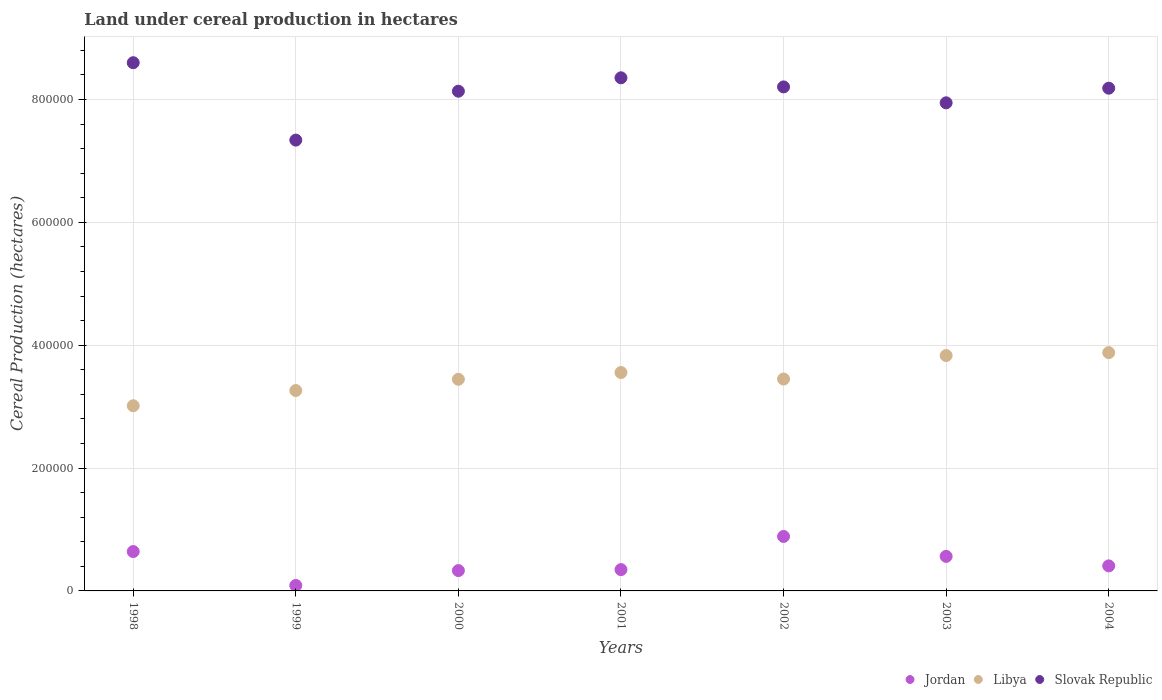How many different coloured dotlines are there?
Your answer should be compact. 3. Is the number of dotlines equal to the number of legend labels?
Offer a very short reply. Yes. What is the land under cereal production in Jordan in 2003?
Your answer should be very brief. 5.62e+04. Across all years, what is the maximum land under cereal production in Slovak Republic?
Your answer should be compact. 8.60e+05. Across all years, what is the minimum land under cereal production in Libya?
Your response must be concise. 3.01e+05. In which year was the land under cereal production in Jordan maximum?
Make the answer very short. 2002. What is the total land under cereal production in Jordan in the graph?
Provide a succinct answer. 3.26e+05. What is the difference between the land under cereal production in Libya in 1998 and that in 2003?
Your answer should be very brief. -8.17e+04. What is the difference between the land under cereal production in Slovak Republic in 2004 and the land under cereal production in Libya in 2001?
Provide a short and direct response. 4.63e+05. What is the average land under cereal production in Libya per year?
Offer a very short reply. 3.49e+05. In the year 2001, what is the difference between the land under cereal production in Slovak Republic and land under cereal production in Jordan?
Ensure brevity in your answer.  8.01e+05. What is the ratio of the land under cereal production in Slovak Republic in 1999 to that in 2003?
Your response must be concise. 0.92. Is the land under cereal production in Libya in 2002 less than that in 2003?
Provide a succinct answer. Yes. Is the difference between the land under cereal production in Slovak Republic in 1999 and 2002 greater than the difference between the land under cereal production in Jordan in 1999 and 2002?
Keep it short and to the point. No. What is the difference between the highest and the second highest land under cereal production in Slovak Republic?
Make the answer very short. 2.46e+04. What is the difference between the highest and the lowest land under cereal production in Jordan?
Offer a very short reply. 7.98e+04. In how many years, is the land under cereal production in Jordan greater than the average land under cereal production in Jordan taken over all years?
Provide a short and direct response. 3. Is the sum of the land under cereal production in Slovak Republic in 1999 and 2002 greater than the maximum land under cereal production in Libya across all years?
Your answer should be compact. Yes. Is it the case that in every year, the sum of the land under cereal production in Jordan and land under cereal production in Slovak Republic  is greater than the land under cereal production in Libya?
Provide a succinct answer. Yes. Does the land under cereal production in Jordan monotonically increase over the years?
Make the answer very short. No. Is the land under cereal production in Jordan strictly greater than the land under cereal production in Slovak Republic over the years?
Give a very brief answer. No. How many dotlines are there?
Keep it short and to the point. 3. How many years are there in the graph?
Ensure brevity in your answer.  7. What is the difference between two consecutive major ticks on the Y-axis?
Offer a very short reply. 2.00e+05. Are the values on the major ticks of Y-axis written in scientific E-notation?
Give a very brief answer. No. Does the graph contain grids?
Ensure brevity in your answer.  Yes. Where does the legend appear in the graph?
Provide a short and direct response. Bottom right. How are the legend labels stacked?
Your answer should be compact. Horizontal. What is the title of the graph?
Offer a terse response. Land under cereal production in hectares. What is the label or title of the Y-axis?
Ensure brevity in your answer.  Cereal Production (hectares). What is the Cereal Production (hectares) in Jordan in 1998?
Your response must be concise. 6.41e+04. What is the Cereal Production (hectares) of Libya in 1998?
Offer a terse response. 3.01e+05. What is the Cereal Production (hectares) in Slovak Republic in 1998?
Provide a short and direct response. 8.60e+05. What is the Cereal Production (hectares) of Jordan in 1999?
Your answer should be very brief. 8880. What is the Cereal Production (hectares) in Libya in 1999?
Your response must be concise. 3.26e+05. What is the Cereal Production (hectares) in Slovak Republic in 1999?
Keep it short and to the point. 7.34e+05. What is the Cereal Production (hectares) of Jordan in 2000?
Give a very brief answer. 3.31e+04. What is the Cereal Production (hectares) of Libya in 2000?
Your response must be concise. 3.44e+05. What is the Cereal Production (hectares) in Slovak Republic in 2000?
Offer a very short reply. 8.13e+05. What is the Cereal Production (hectares) in Jordan in 2001?
Give a very brief answer. 3.47e+04. What is the Cereal Production (hectares) of Libya in 2001?
Provide a short and direct response. 3.56e+05. What is the Cereal Production (hectares) of Slovak Republic in 2001?
Offer a very short reply. 8.35e+05. What is the Cereal Production (hectares) of Jordan in 2002?
Give a very brief answer. 8.87e+04. What is the Cereal Production (hectares) in Libya in 2002?
Offer a terse response. 3.45e+05. What is the Cereal Production (hectares) in Slovak Republic in 2002?
Keep it short and to the point. 8.20e+05. What is the Cereal Production (hectares) in Jordan in 2003?
Your answer should be compact. 5.62e+04. What is the Cereal Production (hectares) in Libya in 2003?
Give a very brief answer. 3.83e+05. What is the Cereal Production (hectares) of Slovak Republic in 2003?
Provide a short and direct response. 7.95e+05. What is the Cereal Production (hectares) of Jordan in 2004?
Offer a very short reply. 4.08e+04. What is the Cereal Production (hectares) in Libya in 2004?
Your response must be concise. 3.88e+05. What is the Cereal Production (hectares) of Slovak Republic in 2004?
Your response must be concise. 8.18e+05. Across all years, what is the maximum Cereal Production (hectares) of Jordan?
Provide a succinct answer. 8.87e+04. Across all years, what is the maximum Cereal Production (hectares) of Libya?
Provide a short and direct response. 3.88e+05. Across all years, what is the maximum Cereal Production (hectares) of Slovak Republic?
Make the answer very short. 8.60e+05. Across all years, what is the minimum Cereal Production (hectares) in Jordan?
Offer a very short reply. 8880. Across all years, what is the minimum Cereal Production (hectares) of Libya?
Offer a very short reply. 3.01e+05. Across all years, what is the minimum Cereal Production (hectares) in Slovak Republic?
Ensure brevity in your answer.  7.34e+05. What is the total Cereal Production (hectares) in Jordan in the graph?
Provide a succinct answer. 3.26e+05. What is the total Cereal Production (hectares) in Libya in the graph?
Give a very brief answer. 2.44e+06. What is the total Cereal Production (hectares) of Slovak Republic in the graph?
Your response must be concise. 5.68e+06. What is the difference between the Cereal Production (hectares) of Jordan in 1998 and that in 1999?
Your answer should be compact. 5.52e+04. What is the difference between the Cereal Production (hectares) in Libya in 1998 and that in 1999?
Give a very brief answer. -2.48e+04. What is the difference between the Cereal Production (hectares) in Slovak Republic in 1998 and that in 1999?
Ensure brevity in your answer.  1.26e+05. What is the difference between the Cereal Production (hectares) of Jordan in 1998 and that in 2000?
Offer a terse response. 3.10e+04. What is the difference between the Cereal Production (hectares) of Libya in 1998 and that in 2000?
Ensure brevity in your answer.  -4.31e+04. What is the difference between the Cereal Production (hectares) in Slovak Republic in 1998 and that in 2000?
Keep it short and to the point. 4.64e+04. What is the difference between the Cereal Production (hectares) in Jordan in 1998 and that in 2001?
Ensure brevity in your answer.  2.94e+04. What is the difference between the Cereal Production (hectares) of Libya in 1998 and that in 2001?
Your response must be concise. -5.41e+04. What is the difference between the Cereal Production (hectares) of Slovak Republic in 1998 and that in 2001?
Ensure brevity in your answer.  2.46e+04. What is the difference between the Cereal Production (hectares) in Jordan in 1998 and that in 2002?
Give a very brief answer. -2.46e+04. What is the difference between the Cereal Production (hectares) of Libya in 1998 and that in 2002?
Provide a short and direct response. -4.35e+04. What is the difference between the Cereal Production (hectares) of Slovak Republic in 1998 and that in 2002?
Give a very brief answer. 3.94e+04. What is the difference between the Cereal Production (hectares) in Jordan in 1998 and that in 2003?
Keep it short and to the point. 7858. What is the difference between the Cereal Production (hectares) in Libya in 1998 and that in 2003?
Offer a very short reply. -8.17e+04. What is the difference between the Cereal Production (hectares) of Slovak Republic in 1998 and that in 2003?
Provide a succinct answer. 6.53e+04. What is the difference between the Cereal Production (hectares) of Jordan in 1998 and that in 2004?
Your response must be concise. 2.33e+04. What is the difference between the Cereal Production (hectares) of Libya in 1998 and that in 2004?
Your answer should be very brief. -8.65e+04. What is the difference between the Cereal Production (hectares) of Slovak Republic in 1998 and that in 2004?
Keep it short and to the point. 4.15e+04. What is the difference between the Cereal Production (hectares) of Jordan in 1999 and that in 2000?
Offer a terse response. -2.42e+04. What is the difference between the Cereal Production (hectares) of Libya in 1999 and that in 2000?
Offer a very short reply. -1.83e+04. What is the difference between the Cereal Production (hectares) in Slovak Republic in 1999 and that in 2000?
Your answer should be very brief. -7.96e+04. What is the difference between the Cereal Production (hectares) of Jordan in 1999 and that in 2001?
Offer a very short reply. -2.58e+04. What is the difference between the Cereal Production (hectares) in Libya in 1999 and that in 2001?
Ensure brevity in your answer.  -2.93e+04. What is the difference between the Cereal Production (hectares) of Slovak Republic in 1999 and that in 2001?
Make the answer very short. -1.01e+05. What is the difference between the Cereal Production (hectares) of Jordan in 1999 and that in 2002?
Your response must be concise. -7.98e+04. What is the difference between the Cereal Production (hectares) of Libya in 1999 and that in 2002?
Offer a terse response. -1.87e+04. What is the difference between the Cereal Production (hectares) in Slovak Republic in 1999 and that in 2002?
Your answer should be very brief. -8.66e+04. What is the difference between the Cereal Production (hectares) of Jordan in 1999 and that in 2003?
Keep it short and to the point. -4.73e+04. What is the difference between the Cereal Production (hectares) of Libya in 1999 and that in 2003?
Offer a very short reply. -5.69e+04. What is the difference between the Cereal Production (hectares) of Slovak Republic in 1999 and that in 2003?
Offer a very short reply. -6.07e+04. What is the difference between the Cereal Production (hectares) of Jordan in 1999 and that in 2004?
Offer a very short reply. -3.19e+04. What is the difference between the Cereal Production (hectares) of Libya in 1999 and that in 2004?
Offer a very short reply. -6.17e+04. What is the difference between the Cereal Production (hectares) of Slovak Republic in 1999 and that in 2004?
Your response must be concise. -8.45e+04. What is the difference between the Cereal Production (hectares) in Jordan in 2000 and that in 2001?
Give a very brief answer. -1591. What is the difference between the Cereal Production (hectares) of Libya in 2000 and that in 2001?
Provide a succinct answer. -1.10e+04. What is the difference between the Cereal Production (hectares) in Slovak Republic in 2000 and that in 2001?
Ensure brevity in your answer.  -2.18e+04. What is the difference between the Cereal Production (hectares) in Jordan in 2000 and that in 2002?
Offer a terse response. -5.56e+04. What is the difference between the Cereal Production (hectares) in Libya in 2000 and that in 2002?
Offer a terse response. -398. What is the difference between the Cereal Production (hectares) in Slovak Republic in 2000 and that in 2002?
Your answer should be compact. -6992. What is the difference between the Cereal Production (hectares) in Jordan in 2000 and that in 2003?
Keep it short and to the point. -2.31e+04. What is the difference between the Cereal Production (hectares) in Libya in 2000 and that in 2003?
Give a very brief answer. -3.86e+04. What is the difference between the Cereal Production (hectares) in Slovak Republic in 2000 and that in 2003?
Make the answer very short. 1.89e+04. What is the difference between the Cereal Production (hectares) of Jordan in 2000 and that in 2004?
Provide a short and direct response. -7654. What is the difference between the Cereal Production (hectares) of Libya in 2000 and that in 2004?
Your answer should be very brief. -4.34e+04. What is the difference between the Cereal Production (hectares) in Slovak Republic in 2000 and that in 2004?
Provide a succinct answer. -4902. What is the difference between the Cereal Production (hectares) in Jordan in 2001 and that in 2002?
Provide a short and direct response. -5.40e+04. What is the difference between the Cereal Production (hectares) of Libya in 2001 and that in 2002?
Give a very brief answer. 1.06e+04. What is the difference between the Cereal Production (hectares) in Slovak Republic in 2001 and that in 2002?
Keep it short and to the point. 1.48e+04. What is the difference between the Cereal Production (hectares) in Jordan in 2001 and that in 2003?
Give a very brief answer. -2.15e+04. What is the difference between the Cereal Production (hectares) in Libya in 2001 and that in 2003?
Offer a very short reply. -2.76e+04. What is the difference between the Cereal Production (hectares) in Slovak Republic in 2001 and that in 2003?
Your answer should be compact. 4.07e+04. What is the difference between the Cereal Production (hectares) in Jordan in 2001 and that in 2004?
Provide a short and direct response. -6063. What is the difference between the Cereal Production (hectares) of Libya in 2001 and that in 2004?
Your answer should be compact. -3.24e+04. What is the difference between the Cereal Production (hectares) in Slovak Republic in 2001 and that in 2004?
Provide a short and direct response. 1.69e+04. What is the difference between the Cereal Production (hectares) of Jordan in 2002 and that in 2003?
Provide a succinct answer. 3.25e+04. What is the difference between the Cereal Production (hectares) of Libya in 2002 and that in 2003?
Your answer should be compact. -3.82e+04. What is the difference between the Cereal Production (hectares) in Slovak Republic in 2002 and that in 2003?
Your response must be concise. 2.59e+04. What is the difference between the Cereal Production (hectares) in Jordan in 2002 and that in 2004?
Give a very brief answer. 4.79e+04. What is the difference between the Cereal Production (hectares) of Libya in 2002 and that in 2004?
Ensure brevity in your answer.  -4.30e+04. What is the difference between the Cereal Production (hectares) of Slovak Republic in 2002 and that in 2004?
Offer a very short reply. 2090. What is the difference between the Cereal Production (hectares) in Jordan in 2003 and that in 2004?
Keep it short and to the point. 1.55e+04. What is the difference between the Cereal Production (hectares) in Libya in 2003 and that in 2004?
Provide a succinct answer. -4773. What is the difference between the Cereal Production (hectares) in Slovak Republic in 2003 and that in 2004?
Make the answer very short. -2.38e+04. What is the difference between the Cereal Production (hectares) in Jordan in 1998 and the Cereal Production (hectares) in Libya in 1999?
Keep it short and to the point. -2.62e+05. What is the difference between the Cereal Production (hectares) in Jordan in 1998 and the Cereal Production (hectares) in Slovak Republic in 1999?
Your answer should be very brief. -6.70e+05. What is the difference between the Cereal Production (hectares) in Libya in 1998 and the Cereal Production (hectares) in Slovak Republic in 1999?
Your answer should be compact. -4.32e+05. What is the difference between the Cereal Production (hectares) in Jordan in 1998 and the Cereal Production (hectares) in Libya in 2000?
Your answer should be very brief. -2.80e+05. What is the difference between the Cereal Production (hectares) in Jordan in 1998 and the Cereal Production (hectares) in Slovak Republic in 2000?
Keep it short and to the point. -7.49e+05. What is the difference between the Cereal Production (hectares) of Libya in 1998 and the Cereal Production (hectares) of Slovak Republic in 2000?
Make the answer very short. -5.12e+05. What is the difference between the Cereal Production (hectares) of Jordan in 1998 and the Cereal Production (hectares) of Libya in 2001?
Provide a succinct answer. -2.91e+05. What is the difference between the Cereal Production (hectares) in Jordan in 1998 and the Cereal Production (hectares) in Slovak Republic in 2001?
Offer a terse response. -7.71e+05. What is the difference between the Cereal Production (hectares) of Libya in 1998 and the Cereal Production (hectares) of Slovak Republic in 2001?
Your answer should be very brief. -5.34e+05. What is the difference between the Cereal Production (hectares) in Jordan in 1998 and the Cereal Production (hectares) in Libya in 2002?
Your response must be concise. -2.81e+05. What is the difference between the Cereal Production (hectares) in Jordan in 1998 and the Cereal Production (hectares) in Slovak Republic in 2002?
Offer a terse response. -7.56e+05. What is the difference between the Cereal Production (hectares) of Libya in 1998 and the Cereal Production (hectares) of Slovak Republic in 2002?
Ensure brevity in your answer.  -5.19e+05. What is the difference between the Cereal Production (hectares) in Jordan in 1998 and the Cereal Production (hectares) in Libya in 2003?
Give a very brief answer. -3.19e+05. What is the difference between the Cereal Production (hectares) of Jordan in 1998 and the Cereal Production (hectares) of Slovak Republic in 2003?
Your response must be concise. -7.30e+05. What is the difference between the Cereal Production (hectares) in Libya in 1998 and the Cereal Production (hectares) in Slovak Republic in 2003?
Offer a very short reply. -4.93e+05. What is the difference between the Cereal Production (hectares) of Jordan in 1998 and the Cereal Production (hectares) of Libya in 2004?
Your response must be concise. -3.24e+05. What is the difference between the Cereal Production (hectares) in Jordan in 1998 and the Cereal Production (hectares) in Slovak Republic in 2004?
Keep it short and to the point. -7.54e+05. What is the difference between the Cereal Production (hectares) in Libya in 1998 and the Cereal Production (hectares) in Slovak Republic in 2004?
Your response must be concise. -5.17e+05. What is the difference between the Cereal Production (hectares) of Jordan in 1999 and the Cereal Production (hectares) of Libya in 2000?
Give a very brief answer. -3.36e+05. What is the difference between the Cereal Production (hectares) in Jordan in 1999 and the Cereal Production (hectares) in Slovak Republic in 2000?
Make the answer very short. -8.05e+05. What is the difference between the Cereal Production (hectares) of Libya in 1999 and the Cereal Production (hectares) of Slovak Republic in 2000?
Provide a short and direct response. -4.87e+05. What is the difference between the Cereal Production (hectares) in Jordan in 1999 and the Cereal Production (hectares) in Libya in 2001?
Make the answer very short. -3.47e+05. What is the difference between the Cereal Production (hectares) in Jordan in 1999 and the Cereal Production (hectares) in Slovak Republic in 2001?
Ensure brevity in your answer.  -8.26e+05. What is the difference between the Cereal Production (hectares) of Libya in 1999 and the Cereal Production (hectares) of Slovak Republic in 2001?
Ensure brevity in your answer.  -5.09e+05. What is the difference between the Cereal Production (hectares) of Jordan in 1999 and the Cereal Production (hectares) of Libya in 2002?
Make the answer very short. -3.36e+05. What is the difference between the Cereal Production (hectares) of Jordan in 1999 and the Cereal Production (hectares) of Slovak Republic in 2002?
Your answer should be compact. -8.12e+05. What is the difference between the Cereal Production (hectares) of Libya in 1999 and the Cereal Production (hectares) of Slovak Republic in 2002?
Offer a very short reply. -4.94e+05. What is the difference between the Cereal Production (hectares) of Jordan in 1999 and the Cereal Production (hectares) of Libya in 2003?
Provide a succinct answer. -3.74e+05. What is the difference between the Cereal Production (hectares) of Jordan in 1999 and the Cereal Production (hectares) of Slovak Republic in 2003?
Give a very brief answer. -7.86e+05. What is the difference between the Cereal Production (hectares) in Libya in 1999 and the Cereal Production (hectares) in Slovak Republic in 2003?
Give a very brief answer. -4.68e+05. What is the difference between the Cereal Production (hectares) in Jordan in 1999 and the Cereal Production (hectares) in Libya in 2004?
Your answer should be very brief. -3.79e+05. What is the difference between the Cereal Production (hectares) in Jordan in 1999 and the Cereal Production (hectares) in Slovak Republic in 2004?
Provide a short and direct response. -8.09e+05. What is the difference between the Cereal Production (hectares) of Libya in 1999 and the Cereal Production (hectares) of Slovak Republic in 2004?
Keep it short and to the point. -4.92e+05. What is the difference between the Cereal Production (hectares) in Jordan in 2000 and the Cereal Production (hectares) in Libya in 2001?
Keep it short and to the point. -3.22e+05. What is the difference between the Cereal Production (hectares) of Jordan in 2000 and the Cereal Production (hectares) of Slovak Republic in 2001?
Provide a succinct answer. -8.02e+05. What is the difference between the Cereal Production (hectares) of Libya in 2000 and the Cereal Production (hectares) of Slovak Republic in 2001?
Keep it short and to the point. -4.91e+05. What is the difference between the Cereal Production (hectares) of Jordan in 2000 and the Cereal Production (hectares) of Libya in 2002?
Keep it short and to the point. -3.12e+05. What is the difference between the Cereal Production (hectares) in Jordan in 2000 and the Cereal Production (hectares) in Slovak Republic in 2002?
Your answer should be compact. -7.87e+05. What is the difference between the Cereal Production (hectares) in Libya in 2000 and the Cereal Production (hectares) in Slovak Republic in 2002?
Your response must be concise. -4.76e+05. What is the difference between the Cereal Production (hectares) in Jordan in 2000 and the Cereal Production (hectares) in Libya in 2003?
Keep it short and to the point. -3.50e+05. What is the difference between the Cereal Production (hectares) in Jordan in 2000 and the Cereal Production (hectares) in Slovak Republic in 2003?
Provide a succinct answer. -7.61e+05. What is the difference between the Cereal Production (hectares) in Libya in 2000 and the Cereal Production (hectares) in Slovak Republic in 2003?
Keep it short and to the point. -4.50e+05. What is the difference between the Cereal Production (hectares) in Jordan in 2000 and the Cereal Production (hectares) in Libya in 2004?
Your answer should be very brief. -3.55e+05. What is the difference between the Cereal Production (hectares) in Jordan in 2000 and the Cereal Production (hectares) in Slovak Republic in 2004?
Your answer should be compact. -7.85e+05. What is the difference between the Cereal Production (hectares) of Libya in 2000 and the Cereal Production (hectares) of Slovak Republic in 2004?
Provide a short and direct response. -4.74e+05. What is the difference between the Cereal Production (hectares) in Jordan in 2001 and the Cereal Production (hectares) in Libya in 2002?
Keep it short and to the point. -3.10e+05. What is the difference between the Cereal Production (hectares) in Jordan in 2001 and the Cereal Production (hectares) in Slovak Republic in 2002?
Your response must be concise. -7.86e+05. What is the difference between the Cereal Production (hectares) in Libya in 2001 and the Cereal Production (hectares) in Slovak Republic in 2002?
Offer a very short reply. -4.65e+05. What is the difference between the Cereal Production (hectares) of Jordan in 2001 and the Cereal Production (hectares) of Libya in 2003?
Your response must be concise. -3.48e+05. What is the difference between the Cereal Production (hectares) in Jordan in 2001 and the Cereal Production (hectares) in Slovak Republic in 2003?
Your answer should be very brief. -7.60e+05. What is the difference between the Cereal Production (hectares) of Libya in 2001 and the Cereal Production (hectares) of Slovak Republic in 2003?
Offer a very short reply. -4.39e+05. What is the difference between the Cereal Production (hectares) of Jordan in 2001 and the Cereal Production (hectares) of Libya in 2004?
Your response must be concise. -3.53e+05. What is the difference between the Cereal Production (hectares) in Jordan in 2001 and the Cereal Production (hectares) in Slovak Republic in 2004?
Give a very brief answer. -7.84e+05. What is the difference between the Cereal Production (hectares) in Libya in 2001 and the Cereal Production (hectares) in Slovak Republic in 2004?
Provide a succinct answer. -4.63e+05. What is the difference between the Cereal Production (hectares) of Jordan in 2002 and the Cereal Production (hectares) of Libya in 2003?
Keep it short and to the point. -2.94e+05. What is the difference between the Cereal Production (hectares) of Jordan in 2002 and the Cereal Production (hectares) of Slovak Republic in 2003?
Your answer should be very brief. -7.06e+05. What is the difference between the Cereal Production (hectares) in Libya in 2002 and the Cereal Production (hectares) in Slovak Republic in 2003?
Provide a succinct answer. -4.50e+05. What is the difference between the Cereal Production (hectares) of Jordan in 2002 and the Cereal Production (hectares) of Libya in 2004?
Your answer should be compact. -2.99e+05. What is the difference between the Cereal Production (hectares) in Jordan in 2002 and the Cereal Production (hectares) in Slovak Republic in 2004?
Offer a very short reply. -7.30e+05. What is the difference between the Cereal Production (hectares) in Libya in 2002 and the Cereal Production (hectares) in Slovak Republic in 2004?
Provide a short and direct response. -4.73e+05. What is the difference between the Cereal Production (hectares) of Jordan in 2003 and the Cereal Production (hectares) of Libya in 2004?
Your response must be concise. -3.32e+05. What is the difference between the Cereal Production (hectares) of Jordan in 2003 and the Cereal Production (hectares) of Slovak Republic in 2004?
Your answer should be compact. -7.62e+05. What is the difference between the Cereal Production (hectares) of Libya in 2003 and the Cereal Production (hectares) of Slovak Republic in 2004?
Provide a short and direct response. -4.35e+05. What is the average Cereal Production (hectares) in Jordan per year?
Offer a very short reply. 4.66e+04. What is the average Cereal Production (hectares) in Libya per year?
Your response must be concise. 3.49e+05. What is the average Cereal Production (hectares) in Slovak Republic per year?
Ensure brevity in your answer.  8.11e+05. In the year 1998, what is the difference between the Cereal Production (hectares) in Jordan and Cereal Production (hectares) in Libya?
Offer a terse response. -2.37e+05. In the year 1998, what is the difference between the Cereal Production (hectares) in Jordan and Cereal Production (hectares) in Slovak Republic?
Make the answer very short. -7.96e+05. In the year 1998, what is the difference between the Cereal Production (hectares) of Libya and Cereal Production (hectares) of Slovak Republic?
Ensure brevity in your answer.  -5.58e+05. In the year 1999, what is the difference between the Cereal Production (hectares) in Jordan and Cereal Production (hectares) in Libya?
Make the answer very short. -3.17e+05. In the year 1999, what is the difference between the Cereal Production (hectares) in Jordan and Cereal Production (hectares) in Slovak Republic?
Make the answer very short. -7.25e+05. In the year 1999, what is the difference between the Cereal Production (hectares) in Libya and Cereal Production (hectares) in Slovak Republic?
Offer a terse response. -4.08e+05. In the year 2000, what is the difference between the Cereal Production (hectares) in Jordan and Cereal Production (hectares) in Libya?
Provide a short and direct response. -3.11e+05. In the year 2000, what is the difference between the Cereal Production (hectares) in Jordan and Cereal Production (hectares) in Slovak Republic?
Keep it short and to the point. -7.80e+05. In the year 2000, what is the difference between the Cereal Production (hectares) in Libya and Cereal Production (hectares) in Slovak Republic?
Give a very brief answer. -4.69e+05. In the year 2001, what is the difference between the Cereal Production (hectares) of Jordan and Cereal Production (hectares) of Libya?
Make the answer very short. -3.21e+05. In the year 2001, what is the difference between the Cereal Production (hectares) in Jordan and Cereal Production (hectares) in Slovak Republic?
Your response must be concise. -8.01e+05. In the year 2001, what is the difference between the Cereal Production (hectares) of Libya and Cereal Production (hectares) of Slovak Republic?
Make the answer very short. -4.80e+05. In the year 2002, what is the difference between the Cereal Production (hectares) of Jordan and Cereal Production (hectares) of Libya?
Your response must be concise. -2.56e+05. In the year 2002, what is the difference between the Cereal Production (hectares) of Jordan and Cereal Production (hectares) of Slovak Republic?
Provide a short and direct response. -7.32e+05. In the year 2002, what is the difference between the Cereal Production (hectares) in Libya and Cereal Production (hectares) in Slovak Republic?
Provide a short and direct response. -4.76e+05. In the year 2003, what is the difference between the Cereal Production (hectares) in Jordan and Cereal Production (hectares) in Libya?
Your answer should be very brief. -3.27e+05. In the year 2003, what is the difference between the Cereal Production (hectares) of Jordan and Cereal Production (hectares) of Slovak Republic?
Your answer should be compact. -7.38e+05. In the year 2003, what is the difference between the Cereal Production (hectares) of Libya and Cereal Production (hectares) of Slovak Republic?
Give a very brief answer. -4.11e+05. In the year 2004, what is the difference between the Cereal Production (hectares) of Jordan and Cereal Production (hectares) of Libya?
Provide a succinct answer. -3.47e+05. In the year 2004, what is the difference between the Cereal Production (hectares) in Jordan and Cereal Production (hectares) in Slovak Republic?
Keep it short and to the point. -7.78e+05. In the year 2004, what is the difference between the Cereal Production (hectares) of Libya and Cereal Production (hectares) of Slovak Republic?
Offer a terse response. -4.30e+05. What is the ratio of the Cereal Production (hectares) of Jordan in 1998 to that in 1999?
Make the answer very short. 7.22. What is the ratio of the Cereal Production (hectares) in Libya in 1998 to that in 1999?
Ensure brevity in your answer.  0.92. What is the ratio of the Cereal Production (hectares) of Slovak Republic in 1998 to that in 1999?
Your response must be concise. 1.17. What is the ratio of the Cereal Production (hectares) in Jordan in 1998 to that in 2000?
Give a very brief answer. 1.94. What is the ratio of the Cereal Production (hectares) of Libya in 1998 to that in 2000?
Provide a succinct answer. 0.87. What is the ratio of the Cereal Production (hectares) in Slovak Republic in 1998 to that in 2000?
Ensure brevity in your answer.  1.06. What is the ratio of the Cereal Production (hectares) in Jordan in 1998 to that in 2001?
Make the answer very short. 1.85. What is the ratio of the Cereal Production (hectares) in Libya in 1998 to that in 2001?
Keep it short and to the point. 0.85. What is the ratio of the Cereal Production (hectares) of Slovak Republic in 1998 to that in 2001?
Your answer should be compact. 1.03. What is the ratio of the Cereal Production (hectares) of Jordan in 1998 to that in 2002?
Your answer should be very brief. 0.72. What is the ratio of the Cereal Production (hectares) of Libya in 1998 to that in 2002?
Keep it short and to the point. 0.87. What is the ratio of the Cereal Production (hectares) in Slovak Republic in 1998 to that in 2002?
Keep it short and to the point. 1.05. What is the ratio of the Cereal Production (hectares) in Jordan in 1998 to that in 2003?
Provide a short and direct response. 1.14. What is the ratio of the Cereal Production (hectares) in Libya in 1998 to that in 2003?
Give a very brief answer. 0.79. What is the ratio of the Cereal Production (hectares) in Slovak Republic in 1998 to that in 2003?
Give a very brief answer. 1.08. What is the ratio of the Cereal Production (hectares) in Jordan in 1998 to that in 2004?
Your answer should be compact. 1.57. What is the ratio of the Cereal Production (hectares) of Libya in 1998 to that in 2004?
Provide a succinct answer. 0.78. What is the ratio of the Cereal Production (hectares) of Slovak Republic in 1998 to that in 2004?
Offer a very short reply. 1.05. What is the ratio of the Cereal Production (hectares) in Jordan in 1999 to that in 2000?
Keep it short and to the point. 0.27. What is the ratio of the Cereal Production (hectares) of Libya in 1999 to that in 2000?
Provide a short and direct response. 0.95. What is the ratio of the Cereal Production (hectares) in Slovak Republic in 1999 to that in 2000?
Offer a terse response. 0.9. What is the ratio of the Cereal Production (hectares) of Jordan in 1999 to that in 2001?
Your response must be concise. 0.26. What is the ratio of the Cereal Production (hectares) in Libya in 1999 to that in 2001?
Provide a short and direct response. 0.92. What is the ratio of the Cereal Production (hectares) of Slovak Republic in 1999 to that in 2001?
Offer a terse response. 0.88. What is the ratio of the Cereal Production (hectares) of Jordan in 1999 to that in 2002?
Your answer should be compact. 0.1. What is the ratio of the Cereal Production (hectares) of Libya in 1999 to that in 2002?
Provide a succinct answer. 0.95. What is the ratio of the Cereal Production (hectares) in Slovak Republic in 1999 to that in 2002?
Your answer should be compact. 0.89. What is the ratio of the Cereal Production (hectares) of Jordan in 1999 to that in 2003?
Make the answer very short. 0.16. What is the ratio of the Cereal Production (hectares) in Libya in 1999 to that in 2003?
Provide a short and direct response. 0.85. What is the ratio of the Cereal Production (hectares) in Slovak Republic in 1999 to that in 2003?
Your response must be concise. 0.92. What is the ratio of the Cereal Production (hectares) of Jordan in 1999 to that in 2004?
Ensure brevity in your answer.  0.22. What is the ratio of the Cereal Production (hectares) in Libya in 1999 to that in 2004?
Offer a terse response. 0.84. What is the ratio of the Cereal Production (hectares) in Slovak Republic in 1999 to that in 2004?
Provide a succinct answer. 0.9. What is the ratio of the Cereal Production (hectares) in Jordan in 2000 to that in 2001?
Your answer should be very brief. 0.95. What is the ratio of the Cereal Production (hectares) of Libya in 2000 to that in 2001?
Your answer should be very brief. 0.97. What is the ratio of the Cereal Production (hectares) of Slovak Republic in 2000 to that in 2001?
Your answer should be compact. 0.97. What is the ratio of the Cereal Production (hectares) of Jordan in 2000 to that in 2002?
Keep it short and to the point. 0.37. What is the ratio of the Cereal Production (hectares) in Jordan in 2000 to that in 2003?
Provide a succinct answer. 0.59. What is the ratio of the Cereal Production (hectares) of Libya in 2000 to that in 2003?
Make the answer very short. 0.9. What is the ratio of the Cereal Production (hectares) of Slovak Republic in 2000 to that in 2003?
Your answer should be very brief. 1.02. What is the ratio of the Cereal Production (hectares) of Jordan in 2000 to that in 2004?
Your answer should be very brief. 0.81. What is the ratio of the Cereal Production (hectares) of Libya in 2000 to that in 2004?
Make the answer very short. 0.89. What is the ratio of the Cereal Production (hectares) of Slovak Republic in 2000 to that in 2004?
Your answer should be compact. 0.99. What is the ratio of the Cereal Production (hectares) in Jordan in 2001 to that in 2002?
Give a very brief answer. 0.39. What is the ratio of the Cereal Production (hectares) of Libya in 2001 to that in 2002?
Offer a terse response. 1.03. What is the ratio of the Cereal Production (hectares) in Slovak Republic in 2001 to that in 2002?
Give a very brief answer. 1.02. What is the ratio of the Cereal Production (hectares) of Jordan in 2001 to that in 2003?
Your response must be concise. 0.62. What is the ratio of the Cereal Production (hectares) in Libya in 2001 to that in 2003?
Your answer should be very brief. 0.93. What is the ratio of the Cereal Production (hectares) in Slovak Republic in 2001 to that in 2003?
Offer a very short reply. 1.05. What is the ratio of the Cereal Production (hectares) of Jordan in 2001 to that in 2004?
Make the answer very short. 0.85. What is the ratio of the Cereal Production (hectares) of Libya in 2001 to that in 2004?
Your answer should be very brief. 0.92. What is the ratio of the Cereal Production (hectares) of Slovak Republic in 2001 to that in 2004?
Your answer should be compact. 1.02. What is the ratio of the Cereal Production (hectares) of Jordan in 2002 to that in 2003?
Offer a very short reply. 1.58. What is the ratio of the Cereal Production (hectares) in Libya in 2002 to that in 2003?
Provide a succinct answer. 0.9. What is the ratio of the Cereal Production (hectares) of Slovak Republic in 2002 to that in 2003?
Offer a terse response. 1.03. What is the ratio of the Cereal Production (hectares) of Jordan in 2002 to that in 2004?
Your answer should be compact. 2.18. What is the ratio of the Cereal Production (hectares) in Libya in 2002 to that in 2004?
Provide a short and direct response. 0.89. What is the ratio of the Cereal Production (hectares) in Jordan in 2003 to that in 2004?
Ensure brevity in your answer.  1.38. What is the ratio of the Cereal Production (hectares) in Libya in 2003 to that in 2004?
Your answer should be very brief. 0.99. What is the ratio of the Cereal Production (hectares) in Slovak Republic in 2003 to that in 2004?
Make the answer very short. 0.97. What is the difference between the highest and the second highest Cereal Production (hectares) in Jordan?
Give a very brief answer. 2.46e+04. What is the difference between the highest and the second highest Cereal Production (hectares) in Libya?
Keep it short and to the point. 4773. What is the difference between the highest and the second highest Cereal Production (hectares) of Slovak Republic?
Your answer should be compact. 2.46e+04. What is the difference between the highest and the lowest Cereal Production (hectares) in Jordan?
Make the answer very short. 7.98e+04. What is the difference between the highest and the lowest Cereal Production (hectares) of Libya?
Ensure brevity in your answer.  8.65e+04. What is the difference between the highest and the lowest Cereal Production (hectares) in Slovak Republic?
Keep it short and to the point. 1.26e+05. 